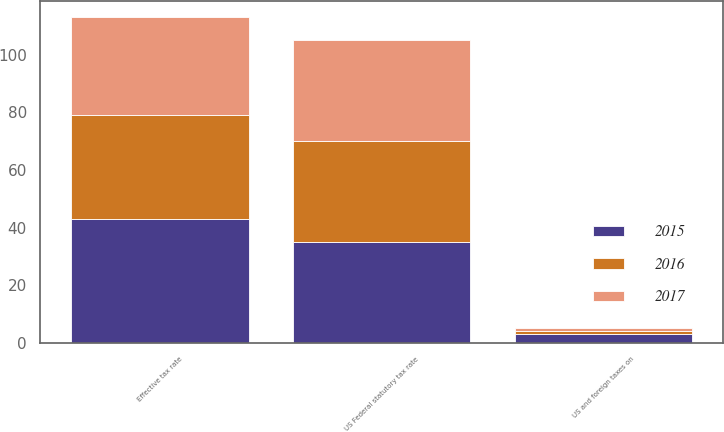Convert chart to OTSL. <chart><loc_0><loc_0><loc_500><loc_500><stacked_bar_chart><ecel><fcel>US Federal statutory tax rate<fcel>US and foreign taxes on<fcel>Effective tax rate<nl><fcel>2017<fcel>35<fcel>1<fcel>34<nl><fcel>2016<fcel>35<fcel>1<fcel>36<nl><fcel>2015<fcel>35<fcel>3<fcel>43<nl></chart> 